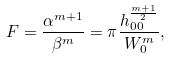<formula> <loc_0><loc_0><loc_500><loc_500>F = \frac { \alpha ^ { m + 1 } } { \beta ^ { m } } = \pi \frac { h _ { 0 0 } ^ { \frac { m + 1 } { 2 } } } { W _ { 0 } ^ { m } } ,</formula> 